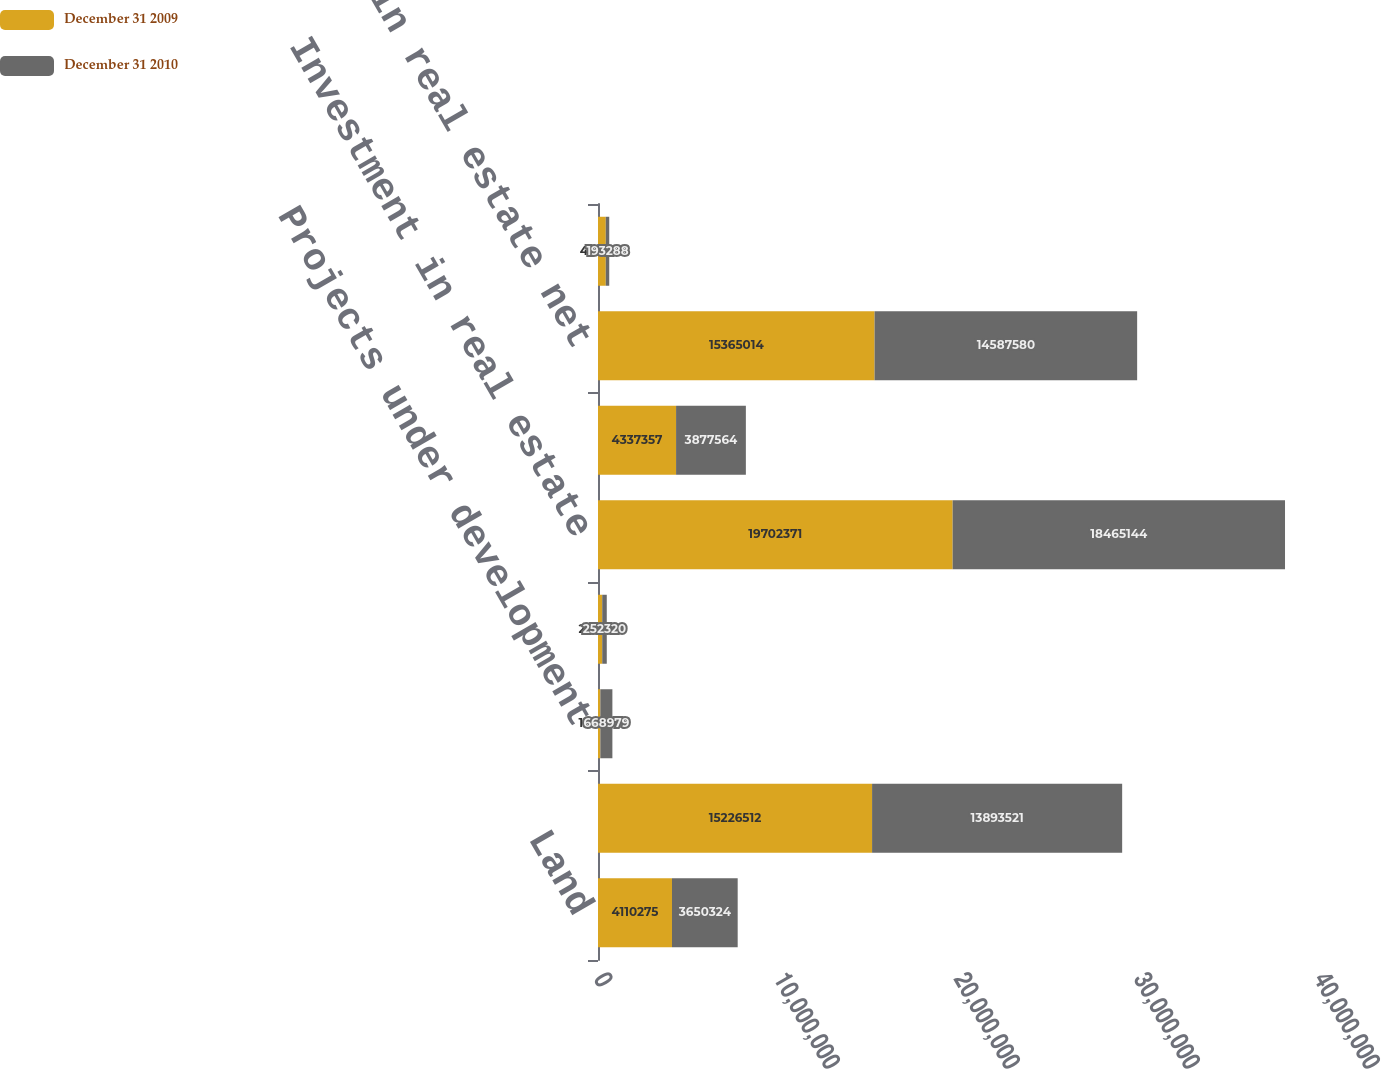<chart> <loc_0><loc_0><loc_500><loc_500><stacked_bar_chart><ecel><fcel>Land<fcel>Depreciable property<fcel>Projects under development<fcel>Land held for development<fcel>Investment in real estate<fcel>Accumulated depreciation<fcel>Investment in real estate net<fcel>Cash and cash equivalents<nl><fcel>December 31 2009<fcel>4.11028e+06<fcel>1.52265e+07<fcel>130337<fcel>235247<fcel>1.97024e+07<fcel>4.33736e+06<fcel>1.5365e+07<fcel>431408<nl><fcel>December 31 2010<fcel>3.65032e+06<fcel>1.38935e+07<fcel>668979<fcel>252320<fcel>1.84651e+07<fcel>3.87756e+06<fcel>1.45876e+07<fcel>193288<nl></chart> 